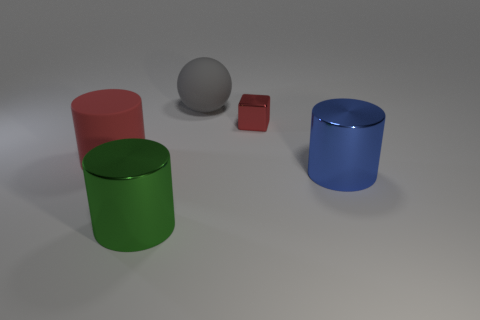Is there any object that appears to be in motion, or are all the objects stationary? All the objects in the image appear to be stationary. There are no indications of motion such as blurring or dynamic poses that would imply movement. Each object casts a clear and distinct shadow, which suggests that they are at rest at the moment the image was taken. 